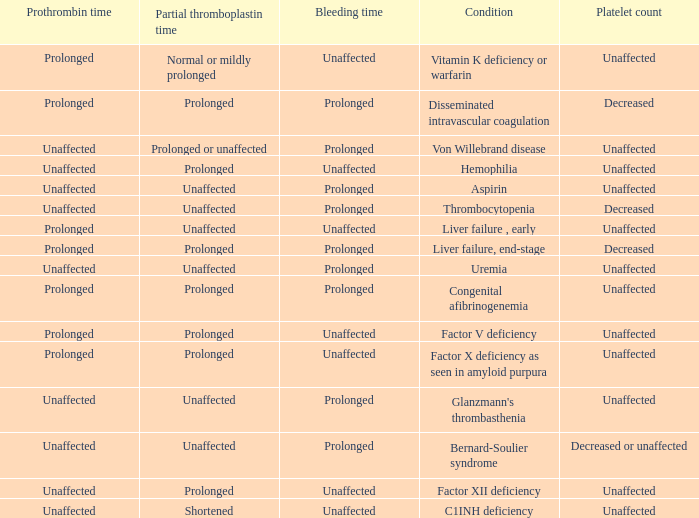Which Condition has an unaffected Prothrombin time and a Bleeding time, and a Partial thromboplastin time of prolonged? Hemophilia, Factor XII deficiency. 